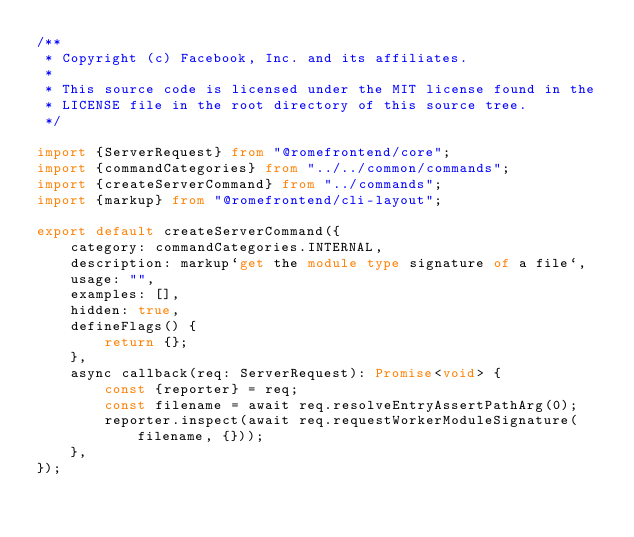<code> <loc_0><loc_0><loc_500><loc_500><_TypeScript_>/**
 * Copyright (c) Facebook, Inc. and its affiliates.
 *
 * This source code is licensed under the MIT license found in the
 * LICENSE file in the root directory of this source tree.
 */

import {ServerRequest} from "@romefrontend/core";
import {commandCategories} from "../../common/commands";
import {createServerCommand} from "../commands";
import {markup} from "@romefrontend/cli-layout";

export default createServerCommand({
	category: commandCategories.INTERNAL,
	description: markup`get the module type signature of a file`,
	usage: "",
	examples: [],
	hidden: true,
	defineFlags() {
		return {};
	},
	async callback(req: ServerRequest): Promise<void> {
		const {reporter} = req;
		const filename = await req.resolveEntryAssertPathArg(0);
		reporter.inspect(await req.requestWorkerModuleSignature(filename, {}));
	},
});
</code> 